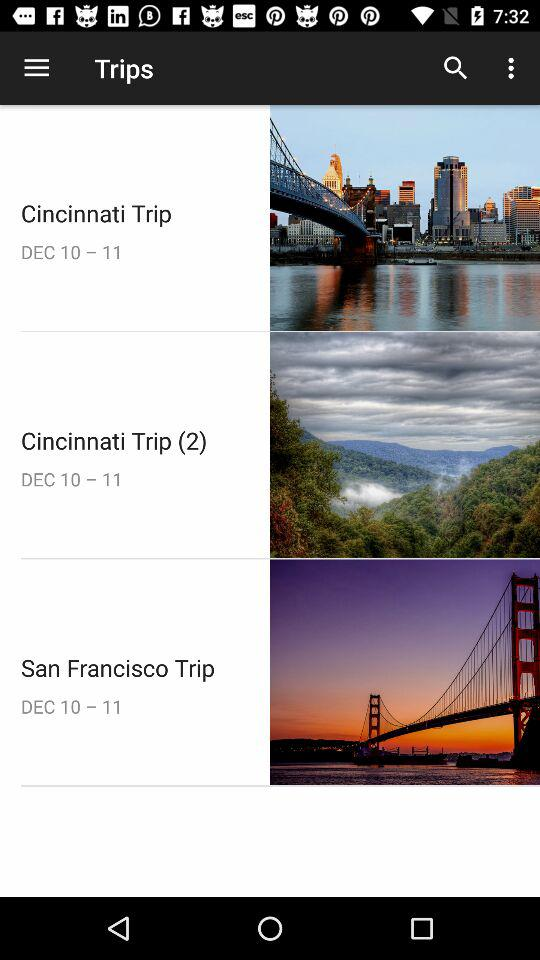What is the date range of the "Cincinnati Trip"? The date range of the "Cincinnati Trip" is from December 10 to December 11. 